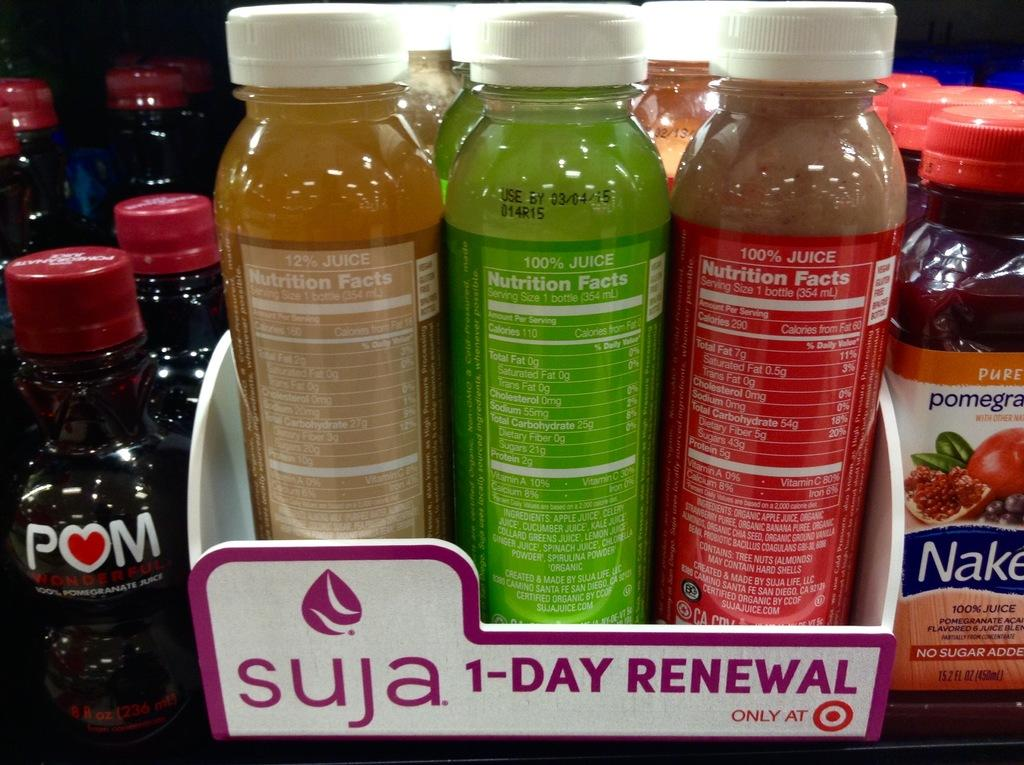<image>
Share a concise interpretation of the image provided. The bottle to the right contains pure pomegranate. 